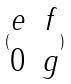<formula> <loc_0><loc_0><loc_500><loc_500>( \begin{matrix} e & f \\ 0 & g \end{matrix} )</formula> 